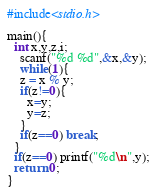Convert code to text. <code><loc_0><loc_0><loc_500><loc_500><_C_>#include<stdio.h>

main(){
  int x,y,z,i;
    scanf("%d %d",&x,&y);
    while(1){
    z = x % y;
    if(z!=0){
      x=y;
      y=z;
    }
    if(z==0) break;
  }
  if(z==0) printf("%d\n",y);
  return 0;
}</code> 